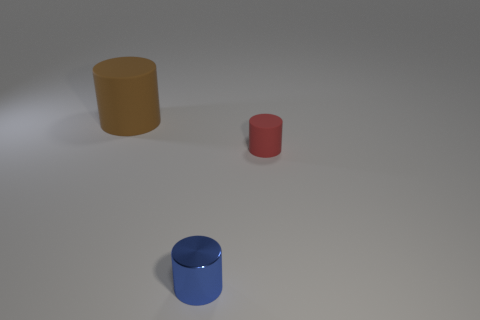Add 2 green blocks. How many objects exist? 5 Subtract all tiny cylinders. How many cylinders are left? 1 Subtract 3 cylinders. How many cylinders are left? 0 Add 3 tiny blue shiny objects. How many tiny blue shiny objects exist? 4 Subtract all blue cylinders. How many cylinders are left? 2 Subtract 0 green cylinders. How many objects are left? 3 Subtract all gray cylinders. Subtract all green balls. How many cylinders are left? 3 Subtract all cyan cubes. How many yellow cylinders are left? 0 Subtract all cyan blocks. Subtract all metal cylinders. How many objects are left? 2 Add 1 tiny red things. How many tiny red things are left? 2 